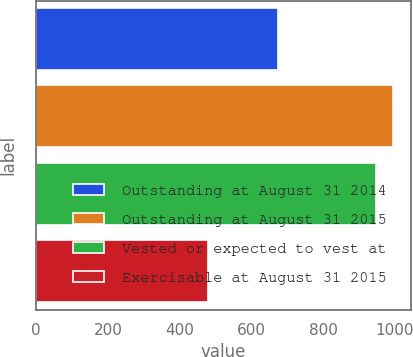<chart> <loc_0><loc_0><loc_500><loc_500><bar_chart><fcel>Outstanding at August 31 2014<fcel>Outstanding at August 31 2015<fcel>Vested or expected to vest at<fcel>Exercisable at August 31 2015<nl><fcel>674<fcel>996.1<fcel>948<fcel>478<nl></chart> 